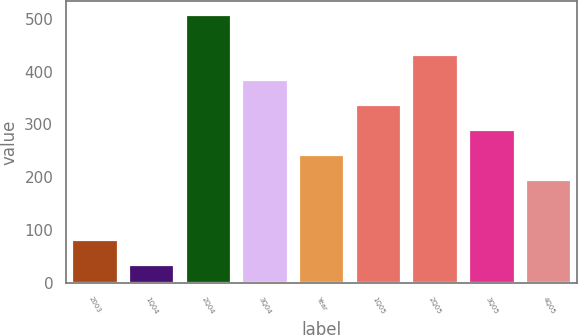Convert chart to OTSL. <chart><loc_0><loc_0><loc_500><loc_500><bar_chart><fcel>2003<fcel>1Q04<fcel>2Q04<fcel>3Q04<fcel>Year<fcel>1Q05<fcel>2Q05<fcel>3Q05<fcel>4Q05<nl><fcel>80.5<fcel>33<fcel>508<fcel>384<fcel>241.5<fcel>336.5<fcel>431.5<fcel>289<fcel>194<nl></chart> 